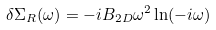<formula> <loc_0><loc_0><loc_500><loc_500>\delta \Sigma _ { R } ( \omega ) = - i B _ { 2 D } \omega ^ { 2 } \ln ( - i \omega )</formula> 